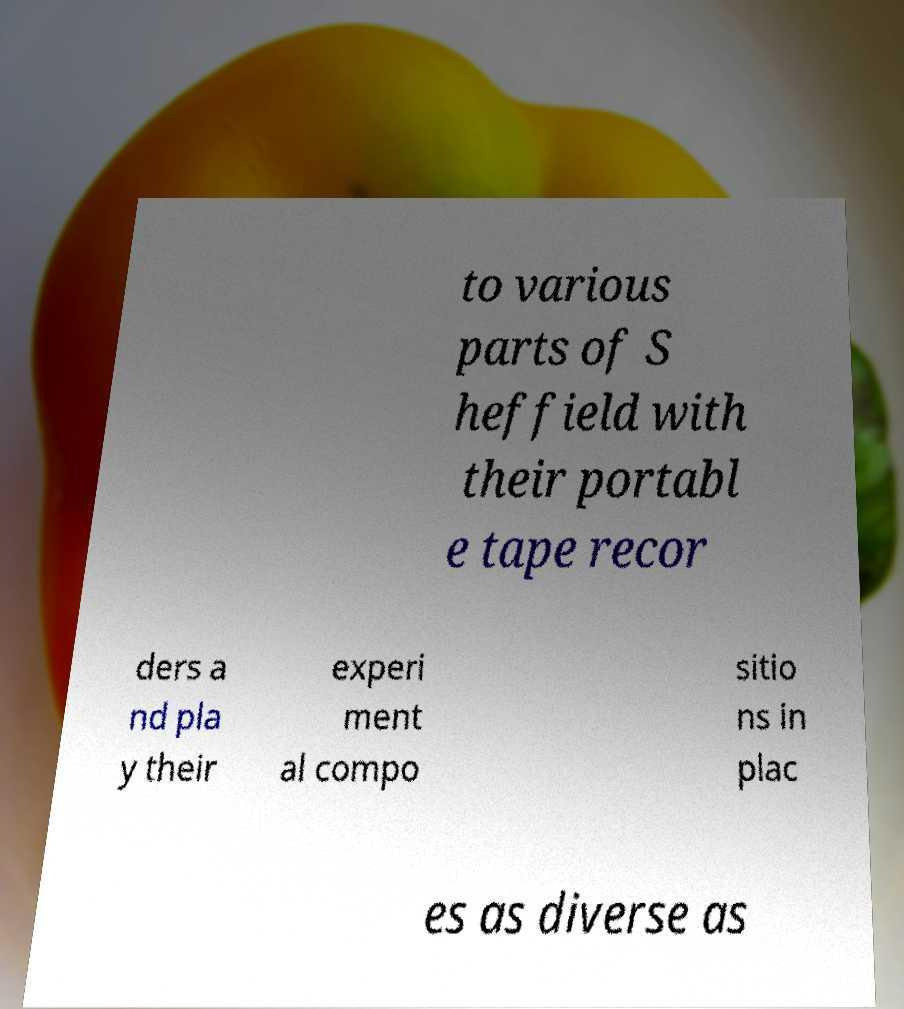I need the written content from this picture converted into text. Can you do that? to various parts of S heffield with their portabl e tape recor ders a nd pla y their experi ment al compo sitio ns in plac es as diverse as 